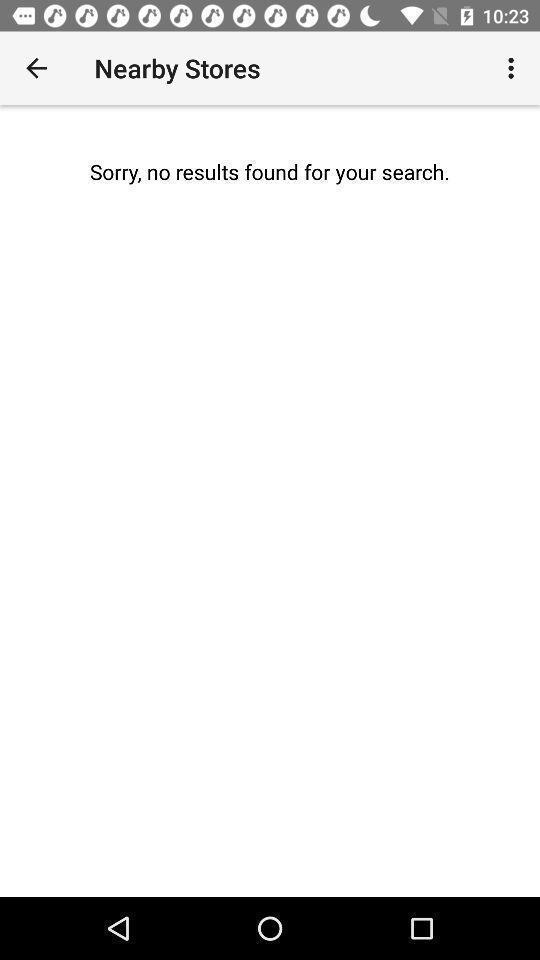Explain the elements present in this screenshot. Search results showing for nearby stores on an app. 